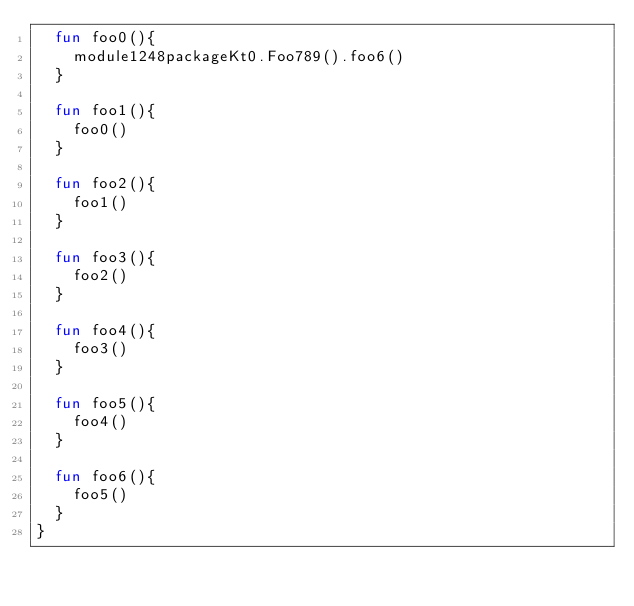Convert code to text. <code><loc_0><loc_0><loc_500><loc_500><_Kotlin_>  fun foo0(){
    module1248packageKt0.Foo789().foo6()
  }

  fun foo1(){
    foo0()
  }

  fun foo2(){
    foo1()
  }

  fun foo3(){
    foo2()
  }

  fun foo4(){
    foo3()
  }

  fun foo5(){
    foo4()
  }

  fun foo6(){
    foo5()
  }
}</code> 